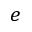<formula> <loc_0><loc_0><loc_500><loc_500>e</formula> 